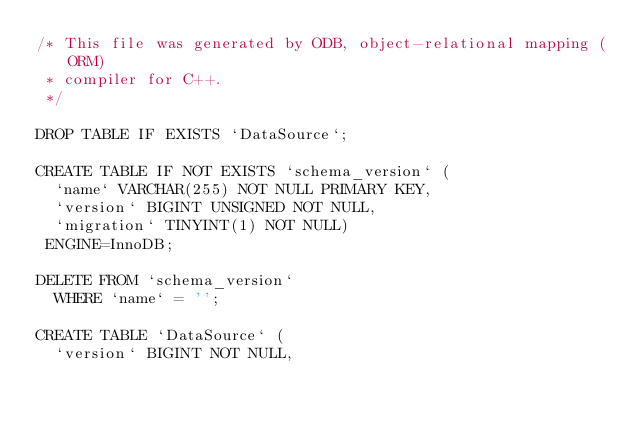<code> <loc_0><loc_0><loc_500><loc_500><_SQL_>/* This file was generated by ODB, object-relational mapping (ORM)
 * compiler for C++.
 */

DROP TABLE IF EXISTS `DataSource`;

CREATE TABLE IF NOT EXISTS `schema_version` (
  `name` VARCHAR(255) NOT NULL PRIMARY KEY,
  `version` BIGINT UNSIGNED NOT NULL,
  `migration` TINYINT(1) NOT NULL)
 ENGINE=InnoDB;

DELETE FROM `schema_version`
  WHERE `name` = '';

CREATE TABLE `DataSource` (
  `version` BIGINT NOT NULL,</code> 